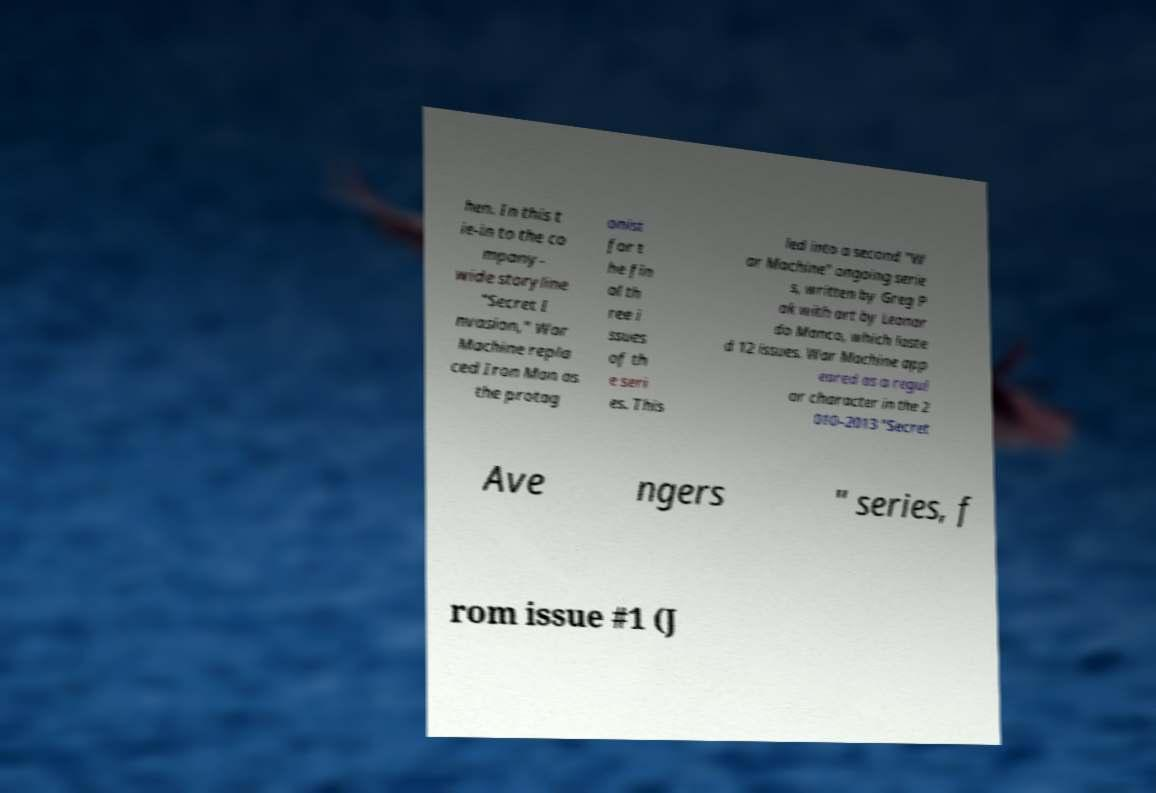What messages or text are displayed in this image? I need them in a readable, typed format. hen. In this t ie-in to the co mpany- wide storyline "Secret I nvasion," War Machine repla ced Iron Man as the protag onist for t he fin al th ree i ssues of th e seri es. This led into a second "W ar Machine" ongoing serie s, written by Greg P ak with art by Leonar do Manco, which laste d 12 issues. War Machine app eared as a regul ar character in the 2 010–2013 "Secret Ave ngers " series, f rom issue #1 (J 